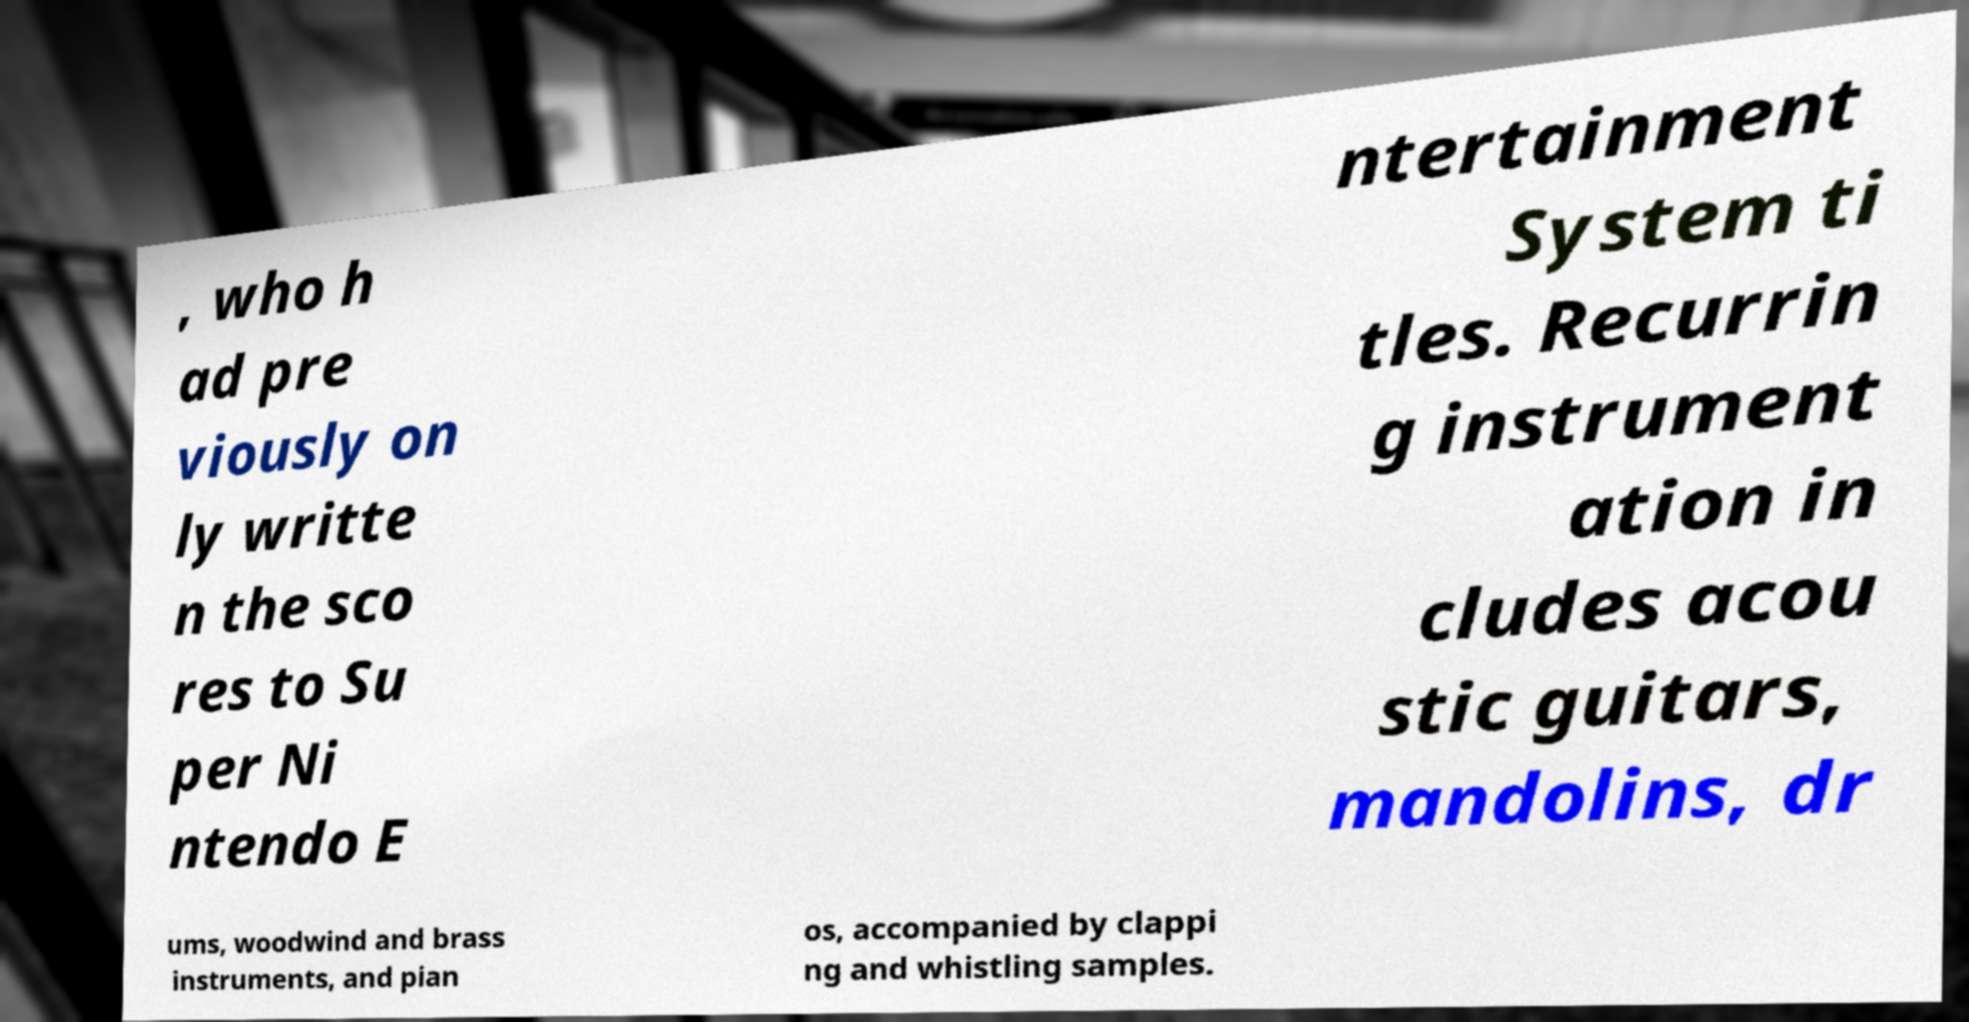I need the written content from this picture converted into text. Can you do that? , who h ad pre viously on ly writte n the sco res to Su per Ni ntendo E ntertainment System ti tles. Recurrin g instrument ation in cludes acou stic guitars, mandolins, dr ums, woodwind and brass instruments, and pian os, accompanied by clappi ng and whistling samples. 